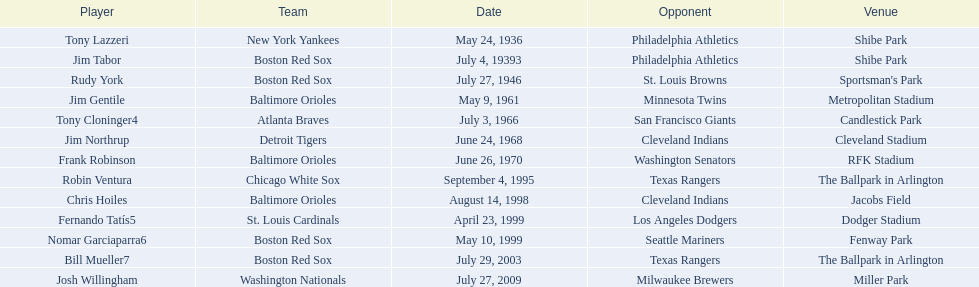What are the monikers of all the athletes? Tony Lazzeri, Jim Tabor, Rudy York, Jim Gentile, Tony Cloninger4, Jim Northrup, Frank Robinson, Robin Ventura, Chris Hoiles, Fernando Tatís5, Nomar Garciaparra6, Bill Mueller7, Josh Willingham. What are the monikers of all the groups maintaining home run records? New York Yankees, Boston Red Sox, Baltimore Orioles, Atlanta Braves, Detroit Tigers, Chicago White Sox, St. Louis Cardinals, Washington Nationals. Which athlete performed for the new york yankees? Tony Lazzeri. 